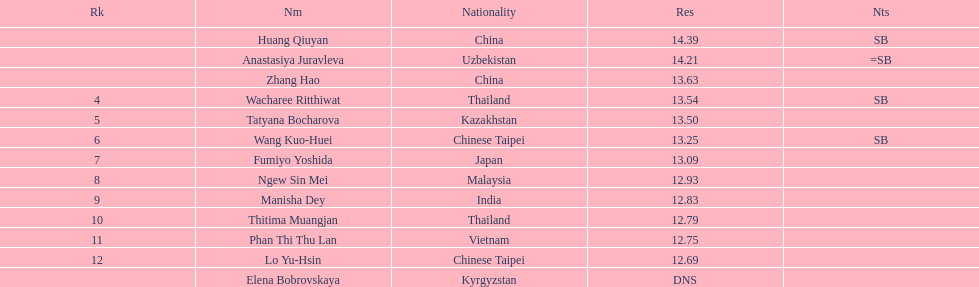What was the average result of the top three jumpers? 14.08. 